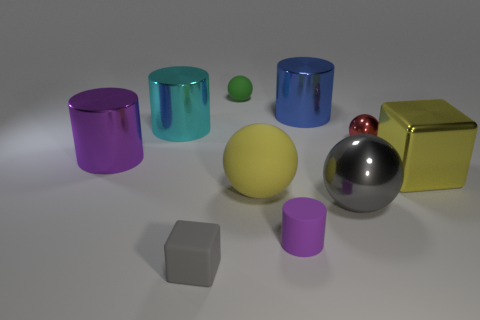Are there any gray matte objects of the same size as the blue metallic cylinder?
Keep it short and to the point. No. What material is the gray object behind the purple object on the right side of the large sphere that is left of the tiny purple matte object?
Provide a short and direct response. Metal. There is a thing behind the blue cylinder; what number of large metal spheres are behind it?
Keep it short and to the point. 0. Does the metal sphere that is behind the yellow metal object have the same size as the large yellow cube?
Make the answer very short. No. What number of red metal things are the same shape as the cyan shiny object?
Offer a very short reply. 0. What shape is the small purple object?
Your response must be concise. Cylinder. Is the number of small spheres that are in front of the big blue metal cylinder the same as the number of small gray cubes?
Your answer should be compact. Yes. Does the purple object in front of the big purple cylinder have the same material as the red sphere?
Offer a very short reply. No. Is the number of small red metal balls left of the large purple cylinder less than the number of rubber cylinders?
Make the answer very short. Yes. What number of metal objects are gray spheres or blue cylinders?
Give a very brief answer. 2. 